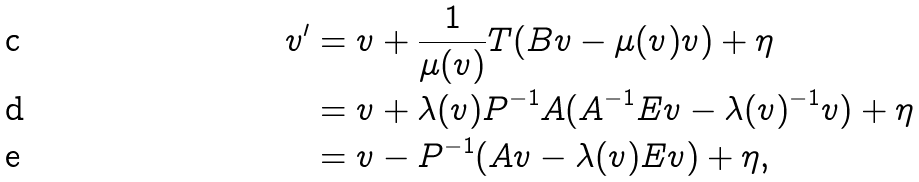Convert formula to latex. <formula><loc_0><loc_0><loc_500><loc_500>v ^ { \prime } & = v + \frac { 1 } { \mu ( v ) } T ( B v - \mu ( v ) v ) + \eta \\ & = v + \lambda ( v ) P ^ { - 1 } A ( A ^ { - 1 } E v - \lambda ( v ) ^ { - 1 } v ) + \eta \\ & = v - P ^ { - 1 } ( A v - \lambda ( v ) E v ) + \eta ,</formula> 